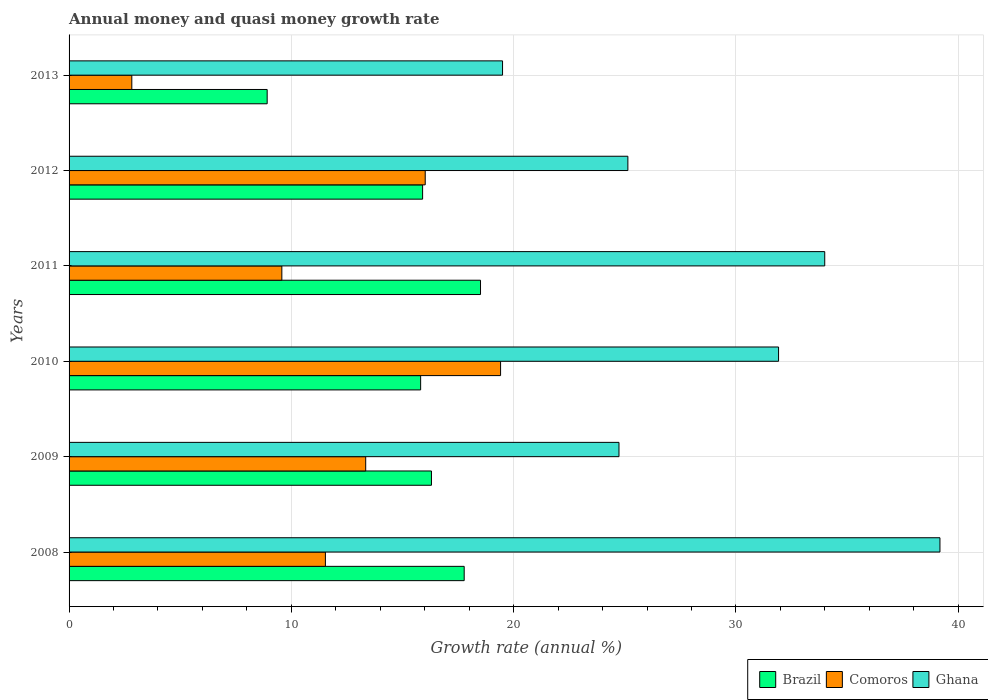How many different coloured bars are there?
Keep it short and to the point. 3. How many groups of bars are there?
Offer a very short reply. 6. Are the number of bars on each tick of the Y-axis equal?
Your answer should be very brief. Yes. How many bars are there on the 6th tick from the top?
Your answer should be very brief. 3. How many bars are there on the 1st tick from the bottom?
Ensure brevity in your answer.  3. What is the label of the 5th group of bars from the top?
Ensure brevity in your answer.  2009. In how many cases, is the number of bars for a given year not equal to the number of legend labels?
Provide a short and direct response. 0. What is the growth rate in Brazil in 2008?
Provide a succinct answer. 17.78. Across all years, what is the maximum growth rate in Brazil?
Give a very brief answer. 18.51. Across all years, what is the minimum growth rate in Comoros?
Your answer should be compact. 2.82. In which year was the growth rate in Ghana maximum?
Keep it short and to the point. 2008. What is the total growth rate in Brazil in the graph?
Provide a succinct answer. 93.22. What is the difference between the growth rate in Ghana in 2008 and that in 2012?
Ensure brevity in your answer.  14.04. What is the difference between the growth rate in Ghana in 2013 and the growth rate in Brazil in 2012?
Offer a very short reply. 3.6. What is the average growth rate in Brazil per year?
Offer a terse response. 15.54. In the year 2013, what is the difference between the growth rate in Ghana and growth rate in Brazil?
Provide a short and direct response. 10.59. In how many years, is the growth rate in Ghana greater than 14 %?
Keep it short and to the point. 6. What is the ratio of the growth rate in Comoros in 2008 to that in 2013?
Ensure brevity in your answer.  4.09. Is the growth rate in Comoros in 2010 less than that in 2013?
Your answer should be very brief. No. Is the difference between the growth rate in Ghana in 2008 and 2013 greater than the difference between the growth rate in Brazil in 2008 and 2013?
Your response must be concise. Yes. What is the difference between the highest and the second highest growth rate in Brazil?
Your answer should be compact. 0.73. What is the difference between the highest and the lowest growth rate in Comoros?
Offer a very short reply. 16.59. What does the 2nd bar from the top in 2012 represents?
Give a very brief answer. Comoros. What does the 2nd bar from the bottom in 2012 represents?
Your answer should be very brief. Comoros. Are the values on the major ticks of X-axis written in scientific E-notation?
Ensure brevity in your answer.  No. How many legend labels are there?
Offer a very short reply. 3. What is the title of the graph?
Offer a terse response. Annual money and quasi money growth rate. What is the label or title of the X-axis?
Make the answer very short. Growth rate (annual %). What is the label or title of the Y-axis?
Provide a short and direct response. Years. What is the Growth rate (annual %) in Brazil in 2008?
Give a very brief answer. 17.78. What is the Growth rate (annual %) in Comoros in 2008?
Offer a terse response. 11.53. What is the Growth rate (annual %) in Ghana in 2008?
Give a very brief answer. 39.18. What is the Growth rate (annual %) of Brazil in 2009?
Make the answer very short. 16.3. What is the Growth rate (annual %) of Comoros in 2009?
Your answer should be compact. 13.34. What is the Growth rate (annual %) of Ghana in 2009?
Keep it short and to the point. 24.74. What is the Growth rate (annual %) of Brazil in 2010?
Offer a very short reply. 15.82. What is the Growth rate (annual %) in Comoros in 2010?
Provide a succinct answer. 19.41. What is the Growth rate (annual %) of Ghana in 2010?
Your answer should be very brief. 31.92. What is the Growth rate (annual %) of Brazil in 2011?
Offer a very short reply. 18.51. What is the Growth rate (annual %) of Comoros in 2011?
Make the answer very short. 9.57. What is the Growth rate (annual %) of Ghana in 2011?
Give a very brief answer. 33.99. What is the Growth rate (annual %) of Brazil in 2012?
Make the answer very short. 15.9. What is the Growth rate (annual %) of Comoros in 2012?
Provide a succinct answer. 16.02. What is the Growth rate (annual %) in Ghana in 2012?
Your answer should be compact. 25.14. What is the Growth rate (annual %) of Brazil in 2013?
Offer a terse response. 8.91. What is the Growth rate (annual %) of Comoros in 2013?
Provide a succinct answer. 2.82. What is the Growth rate (annual %) of Ghana in 2013?
Keep it short and to the point. 19.5. Across all years, what is the maximum Growth rate (annual %) of Brazil?
Provide a short and direct response. 18.51. Across all years, what is the maximum Growth rate (annual %) of Comoros?
Make the answer very short. 19.41. Across all years, what is the maximum Growth rate (annual %) in Ghana?
Offer a very short reply. 39.18. Across all years, what is the minimum Growth rate (annual %) of Brazil?
Your answer should be very brief. 8.91. Across all years, what is the minimum Growth rate (annual %) of Comoros?
Ensure brevity in your answer.  2.82. Across all years, what is the minimum Growth rate (annual %) of Ghana?
Provide a short and direct response. 19.5. What is the total Growth rate (annual %) of Brazil in the graph?
Your answer should be compact. 93.22. What is the total Growth rate (annual %) of Comoros in the graph?
Provide a short and direct response. 72.7. What is the total Growth rate (annual %) of Ghana in the graph?
Your answer should be compact. 174.47. What is the difference between the Growth rate (annual %) of Brazil in 2008 and that in 2009?
Offer a terse response. 1.47. What is the difference between the Growth rate (annual %) of Comoros in 2008 and that in 2009?
Offer a very short reply. -1.81. What is the difference between the Growth rate (annual %) in Ghana in 2008 and that in 2009?
Offer a terse response. 14.44. What is the difference between the Growth rate (annual %) of Brazil in 2008 and that in 2010?
Provide a succinct answer. 1.96. What is the difference between the Growth rate (annual %) in Comoros in 2008 and that in 2010?
Provide a succinct answer. -7.88. What is the difference between the Growth rate (annual %) of Ghana in 2008 and that in 2010?
Your response must be concise. 7.26. What is the difference between the Growth rate (annual %) of Brazil in 2008 and that in 2011?
Your answer should be very brief. -0.73. What is the difference between the Growth rate (annual %) in Comoros in 2008 and that in 2011?
Provide a succinct answer. 1.96. What is the difference between the Growth rate (annual %) in Ghana in 2008 and that in 2011?
Give a very brief answer. 5.18. What is the difference between the Growth rate (annual %) in Brazil in 2008 and that in 2012?
Keep it short and to the point. 1.87. What is the difference between the Growth rate (annual %) in Comoros in 2008 and that in 2012?
Your answer should be compact. -4.49. What is the difference between the Growth rate (annual %) in Ghana in 2008 and that in 2012?
Give a very brief answer. 14.04. What is the difference between the Growth rate (annual %) in Brazil in 2008 and that in 2013?
Make the answer very short. 8.86. What is the difference between the Growth rate (annual %) in Comoros in 2008 and that in 2013?
Your answer should be compact. 8.71. What is the difference between the Growth rate (annual %) of Ghana in 2008 and that in 2013?
Provide a short and direct response. 19.68. What is the difference between the Growth rate (annual %) of Brazil in 2009 and that in 2010?
Keep it short and to the point. 0.49. What is the difference between the Growth rate (annual %) in Comoros in 2009 and that in 2010?
Give a very brief answer. -6.07. What is the difference between the Growth rate (annual %) in Ghana in 2009 and that in 2010?
Provide a succinct answer. -7.18. What is the difference between the Growth rate (annual %) of Brazil in 2009 and that in 2011?
Provide a short and direct response. -2.21. What is the difference between the Growth rate (annual %) of Comoros in 2009 and that in 2011?
Your answer should be compact. 3.77. What is the difference between the Growth rate (annual %) in Ghana in 2009 and that in 2011?
Provide a succinct answer. -9.26. What is the difference between the Growth rate (annual %) in Brazil in 2009 and that in 2012?
Your answer should be compact. 0.4. What is the difference between the Growth rate (annual %) in Comoros in 2009 and that in 2012?
Your answer should be very brief. -2.68. What is the difference between the Growth rate (annual %) in Ghana in 2009 and that in 2012?
Keep it short and to the point. -0.4. What is the difference between the Growth rate (annual %) of Brazil in 2009 and that in 2013?
Your response must be concise. 7.39. What is the difference between the Growth rate (annual %) of Comoros in 2009 and that in 2013?
Make the answer very short. 10.52. What is the difference between the Growth rate (annual %) of Ghana in 2009 and that in 2013?
Your answer should be compact. 5.24. What is the difference between the Growth rate (annual %) of Brazil in 2010 and that in 2011?
Provide a succinct answer. -2.69. What is the difference between the Growth rate (annual %) of Comoros in 2010 and that in 2011?
Provide a succinct answer. 9.84. What is the difference between the Growth rate (annual %) in Ghana in 2010 and that in 2011?
Keep it short and to the point. -2.08. What is the difference between the Growth rate (annual %) in Brazil in 2010 and that in 2012?
Your answer should be very brief. -0.09. What is the difference between the Growth rate (annual %) in Comoros in 2010 and that in 2012?
Offer a very short reply. 3.39. What is the difference between the Growth rate (annual %) of Ghana in 2010 and that in 2012?
Provide a succinct answer. 6.78. What is the difference between the Growth rate (annual %) of Brazil in 2010 and that in 2013?
Keep it short and to the point. 6.9. What is the difference between the Growth rate (annual %) in Comoros in 2010 and that in 2013?
Keep it short and to the point. 16.59. What is the difference between the Growth rate (annual %) in Ghana in 2010 and that in 2013?
Ensure brevity in your answer.  12.42. What is the difference between the Growth rate (annual %) in Brazil in 2011 and that in 2012?
Ensure brevity in your answer.  2.61. What is the difference between the Growth rate (annual %) in Comoros in 2011 and that in 2012?
Provide a short and direct response. -6.45. What is the difference between the Growth rate (annual %) in Ghana in 2011 and that in 2012?
Offer a terse response. 8.86. What is the difference between the Growth rate (annual %) of Brazil in 2011 and that in 2013?
Keep it short and to the point. 9.6. What is the difference between the Growth rate (annual %) in Comoros in 2011 and that in 2013?
Your answer should be compact. 6.75. What is the difference between the Growth rate (annual %) of Ghana in 2011 and that in 2013?
Your response must be concise. 14.49. What is the difference between the Growth rate (annual %) in Brazil in 2012 and that in 2013?
Provide a short and direct response. 6.99. What is the difference between the Growth rate (annual %) in Comoros in 2012 and that in 2013?
Give a very brief answer. 13.2. What is the difference between the Growth rate (annual %) of Ghana in 2012 and that in 2013?
Provide a short and direct response. 5.64. What is the difference between the Growth rate (annual %) of Brazil in 2008 and the Growth rate (annual %) of Comoros in 2009?
Give a very brief answer. 4.43. What is the difference between the Growth rate (annual %) of Brazil in 2008 and the Growth rate (annual %) of Ghana in 2009?
Your answer should be compact. -6.96. What is the difference between the Growth rate (annual %) in Comoros in 2008 and the Growth rate (annual %) in Ghana in 2009?
Keep it short and to the point. -13.21. What is the difference between the Growth rate (annual %) of Brazil in 2008 and the Growth rate (annual %) of Comoros in 2010?
Keep it short and to the point. -1.64. What is the difference between the Growth rate (annual %) of Brazil in 2008 and the Growth rate (annual %) of Ghana in 2010?
Provide a succinct answer. -14.14. What is the difference between the Growth rate (annual %) of Comoros in 2008 and the Growth rate (annual %) of Ghana in 2010?
Your answer should be compact. -20.39. What is the difference between the Growth rate (annual %) in Brazil in 2008 and the Growth rate (annual %) in Comoros in 2011?
Provide a succinct answer. 8.2. What is the difference between the Growth rate (annual %) of Brazil in 2008 and the Growth rate (annual %) of Ghana in 2011?
Your response must be concise. -16.22. What is the difference between the Growth rate (annual %) in Comoros in 2008 and the Growth rate (annual %) in Ghana in 2011?
Offer a very short reply. -22.46. What is the difference between the Growth rate (annual %) in Brazil in 2008 and the Growth rate (annual %) in Comoros in 2012?
Keep it short and to the point. 1.75. What is the difference between the Growth rate (annual %) in Brazil in 2008 and the Growth rate (annual %) in Ghana in 2012?
Keep it short and to the point. -7.36. What is the difference between the Growth rate (annual %) of Comoros in 2008 and the Growth rate (annual %) of Ghana in 2012?
Your answer should be very brief. -13.61. What is the difference between the Growth rate (annual %) of Brazil in 2008 and the Growth rate (annual %) of Comoros in 2013?
Provide a short and direct response. 14.95. What is the difference between the Growth rate (annual %) in Brazil in 2008 and the Growth rate (annual %) in Ghana in 2013?
Your answer should be very brief. -1.73. What is the difference between the Growth rate (annual %) of Comoros in 2008 and the Growth rate (annual %) of Ghana in 2013?
Your answer should be compact. -7.97. What is the difference between the Growth rate (annual %) of Brazil in 2009 and the Growth rate (annual %) of Comoros in 2010?
Provide a succinct answer. -3.11. What is the difference between the Growth rate (annual %) in Brazil in 2009 and the Growth rate (annual %) in Ghana in 2010?
Make the answer very short. -15.62. What is the difference between the Growth rate (annual %) in Comoros in 2009 and the Growth rate (annual %) in Ghana in 2010?
Make the answer very short. -18.57. What is the difference between the Growth rate (annual %) of Brazil in 2009 and the Growth rate (annual %) of Comoros in 2011?
Provide a short and direct response. 6.73. What is the difference between the Growth rate (annual %) of Brazil in 2009 and the Growth rate (annual %) of Ghana in 2011?
Make the answer very short. -17.69. What is the difference between the Growth rate (annual %) of Comoros in 2009 and the Growth rate (annual %) of Ghana in 2011?
Make the answer very short. -20.65. What is the difference between the Growth rate (annual %) in Brazil in 2009 and the Growth rate (annual %) in Comoros in 2012?
Your answer should be compact. 0.28. What is the difference between the Growth rate (annual %) in Brazil in 2009 and the Growth rate (annual %) in Ghana in 2012?
Give a very brief answer. -8.84. What is the difference between the Growth rate (annual %) of Comoros in 2009 and the Growth rate (annual %) of Ghana in 2012?
Make the answer very short. -11.79. What is the difference between the Growth rate (annual %) in Brazil in 2009 and the Growth rate (annual %) in Comoros in 2013?
Give a very brief answer. 13.48. What is the difference between the Growth rate (annual %) in Brazil in 2009 and the Growth rate (annual %) in Ghana in 2013?
Offer a terse response. -3.2. What is the difference between the Growth rate (annual %) in Comoros in 2009 and the Growth rate (annual %) in Ghana in 2013?
Keep it short and to the point. -6.16. What is the difference between the Growth rate (annual %) of Brazil in 2010 and the Growth rate (annual %) of Comoros in 2011?
Ensure brevity in your answer.  6.24. What is the difference between the Growth rate (annual %) in Brazil in 2010 and the Growth rate (annual %) in Ghana in 2011?
Your answer should be very brief. -18.18. What is the difference between the Growth rate (annual %) of Comoros in 2010 and the Growth rate (annual %) of Ghana in 2011?
Offer a very short reply. -14.58. What is the difference between the Growth rate (annual %) in Brazil in 2010 and the Growth rate (annual %) in Comoros in 2012?
Provide a short and direct response. -0.21. What is the difference between the Growth rate (annual %) in Brazil in 2010 and the Growth rate (annual %) in Ghana in 2012?
Offer a terse response. -9.32. What is the difference between the Growth rate (annual %) in Comoros in 2010 and the Growth rate (annual %) in Ghana in 2012?
Provide a succinct answer. -5.73. What is the difference between the Growth rate (annual %) in Brazil in 2010 and the Growth rate (annual %) in Comoros in 2013?
Provide a short and direct response. 12.99. What is the difference between the Growth rate (annual %) of Brazil in 2010 and the Growth rate (annual %) of Ghana in 2013?
Give a very brief answer. -3.68. What is the difference between the Growth rate (annual %) of Comoros in 2010 and the Growth rate (annual %) of Ghana in 2013?
Ensure brevity in your answer.  -0.09. What is the difference between the Growth rate (annual %) in Brazil in 2011 and the Growth rate (annual %) in Comoros in 2012?
Provide a short and direct response. 2.49. What is the difference between the Growth rate (annual %) in Brazil in 2011 and the Growth rate (annual %) in Ghana in 2012?
Ensure brevity in your answer.  -6.63. What is the difference between the Growth rate (annual %) of Comoros in 2011 and the Growth rate (annual %) of Ghana in 2012?
Keep it short and to the point. -15.57. What is the difference between the Growth rate (annual %) of Brazil in 2011 and the Growth rate (annual %) of Comoros in 2013?
Provide a short and direct response. 15.69. What is the difference between the Growth rate (annual %) of Brazil in 2011 and the Growth rate (annual %) of Ghana in 2013?
Give a very brief answer. -0.99. What is the difference between the Growth rate (annual %) in Comoros in 2011 and the Growth rate (annual %) in Ghana in 2013?
Make the answer very short. -9.93. What is the difference between the Growth rate (annual %) of Brazil in 2012 and the Growth rate (annual %) of Comoros in 2013?
Keep it short and to the point. 13.08. What is the difference between the Growth rate (annual %) in Brazil in 2012 and the Growth rate (annual %) in Ghana in 2013?
Make the answer very short. -3.6. What is the difference between the Growth rate (annual %) in Comoros in 2012 and the Growth rate (annual %) in Ghana in 2013?
Provide a succinct answer. -3.48. What is the average Growth rate (annual %) in Brazil per year?
Your answer should be compact. 15.54. What is the average Growth rate (annual %) in Comoros per year?
Your answer should be compact. 12.12. What is the average Growth rate (annual %) of Ghana per year?
Provide a succinct answer. 29.08. In the year 2008, what is the difference between the Growth rate (annual %) in Brazil and Growth rate (annual %) in Comoros?
Provide a short and direct response. 6.24. In the year 2008, what is the difference between the Growth rate (annual %) of Brazil and Growth rate (annual %) of Ghana?
Offer a very short reply. -21.4. In the year 2008, what is the difference between the Growth rate (annual %) of Comoros and Growth rate (annual %) of Ghana?
Ensure brevity in your answer.  -27.65. In the year 2009, what is the difference between the Growth rate (annual %) of Brazil and Growth rate (annual %) of Comoros?
Keep it short and to the point. 2.96. In the year 2009, what is the difference between the Growth rate (annual %) of Brazil and Growth rate (annual %) of Ghana?
Give a very brief answer. -8.44. In the year 2009, what is the difference between the Growth rate (annual %) in Comoros and Growth rate (annual %) in Ghana?
Ensure brevity in your answer.  -11.39. In the year 2010, what is the difference between the Growth rate (annual %) of Brazil and Growth rate (annual %) of Comoros?
Your response must be concise. -3.6. In the year 2010, what is the difference between the Growth rate (annual %) in Brazil and Growth rate (annual %) in Ghana?
Provide a short and direct response. -16.1. In the year 2010, what is the difference between the Growth rate (annual %) of Comoros and Growth rate (annual %) of Ghana?
Give a very brief answer. -12.51. In the year 2011, what is the difference between the Growth rate (annual %) in Brazil and Growth rate (annual %) in Comoros?
Offer a very short reply. 8.94. In the year 2011, what is the difference between the Growth rate (annual %) in Brazil and Growth rate (annual %) in Ghana?
Offer a terse response. -15.48. In the year 2011, what is the difference between the Growth rate (annual %) of Comoros and Growth rate (annual %) of Ghana?
Make the answer very short. -24.42. In the year 2012, what is the difference between the Growth rate (annual %) of Brazil and Growth rate (annual %) of Comoros?
Ensure brevity in your answer.  -0.12. In the year 2012, what is the difference between the Growth rate (annual %) of Brazil and Growth rate (annual %) of Ghana?
Provide a short and direct response. -9.23. In the year 2012, what is the difference between the Growth rate (annual %) of Comoros and Growth rate (annual %) of Ghana?
Keep it short and to the point. -9.12. In the year 2013, what is the difference between the Growth rate (annual %) of Brazil and Growth rate (annual %) of Comoros?
Give a very brief answer. 6.09. In the year 2013, what is the difference between the Growth rate (annual %) in Brazil and Growth rate (annual %) in Ghana?
Make the answer very short. -10.59. In the year 2013, what is the difference between the Growth rate (annual %) in Comoros and Growth rate (annual %) in Ghana?
Offer a terse response. -16.68. What is the ratio of the Growth rate (annual %) of Brazil in 2008 to that in 2009?
Provide a succinct answer. 1.09. What is the ratio of the Growth rate (annual %) in Comoros in 2008 to that in 2009?
Your answer should be very brief. 0.86. What is the ratio of the Growth rate (annual %) of Ghana in 2008 to that in 2009?
Make the answer very short. 1.58. What is the ratio of the Growth rate (annual %) of Brazil in 2008 to that in 2010?
Offer a terse response. 1.12. What is the ratio of the Growth rate (annual %) of Comoros in 2008 to that in 2010?
Your response must be concise. 0.59. What is the ratio of the Growth rate (annual %) in Ghana in 2008 to that in 2010?
Provide a short and direct response. 1.23. What is the ratio of the Growth rate (annual %) of Brazil in 2008 to that in 2011?
Provide a short and direct response. 0.96. What is the ratio of the Growth rate (annual %) in Comoros in 2008 to that in 2011?
Ensure brevity in your answer.  1.2. What is the ratio of the Growth rate (annual %) in Ghana in 2008 to that in 2011?
Your response must be concise. 1.15. What is the ratio of the Growth rate (annual %) in Brazil in 2008 to that in 2012?
Ensure brevity in your answer.  1.12. What is the ratio of the Growth rate (annual %) in Comoros in 2008 to that in 2012?
Keep it short and to the point. 0.72. What is the ratio of the Growth rate (annual %) of Ghana in 2008 to that in 2012?
Give a very brief answer. 1.56. What is the ratio of the Growth rate (annual %) of Brazil in 2008 to that in 2013?
Offer a terse response. 1.99. What is the ratio of the Growth rate (annual %) of Comoros in 2008 to that in 2013?
Make the answer very short. 4.09. What is the ratio of the Growth rate (annual %) in Ghana in 2008 to that in 2013?
Give a very brief answer. 2.01. What is the ratio of the Growth rate (annual %) of Brazil in 2009 to that in 2010?
Offer a very short reply. 1.03. What is the ratio of the Growth rate (annual %) of Comoros in 2009 to that in 2010?
Offer a very short reply. 0.69. What is the ratio of the Growth rate (annual %) in Ghana in 2009 to that in 2010?
Offer a very short reply. 0.78. What is the ratio of the Growth rate (annual %) in Brazil in 2009 to that in 2011?
Your answer should be compact. 0.88. What is the ratio of the Growth rate (annual %) of Comoros in 2009 to that in 2011?
Keep it short and to the point. 1.39. What is the ratio of the Growth rate (annual %) of Ghana in 2009 to that in 2011?
Offer a terse response. 0.73. What is the ratio of the Growth rate (annual %) in Comoros in 2009 to that in 2012?
Your response must be concise. 0.83. What is the ratio of the Growth rate (annual %) of Ghana in 2009 to that in 2012?
Give a very brief answer. 0.98. What is the ratio of the Growth rate (annual %) of Brazil in 2009 to that in 2013?
Ensure brevity in your answer.  1.83. What is the ratio of the Growth rate (annual %) in Comoros in 2009 to that in 2013?
Make the answer very short. 4.73. What is the ratio of the Growth rate (annual %) of Ghana in 2009 to that in 2013?
Provide a succinct answer. 1.27. What is the ratio of the Growth rate (annual %) of Brazil in 2010 to that in 2011?
Offer a very short reply. 0.85. What is the ratio of the Growth rate (annual %) of Comoros in 2010 to that in 2011?
Provide a short and direct response. 2.03. What is the ratio of the Growth rate (annual %) of Ghana in 2010 to that in 2011?
Your answer should be compact. 0.94. What is the ratio of the Growth rate (annual %) of Brazil in 2010 to that in 2012?
Offer a very short reply. 0.99. What is the ratio of the Growth rate (annual %) in Comoros in 2010 to that in 2012?
Make the answer very short. 1.21. What is the ratio of the Growth rate (annual %) of Ghana in 2010 to that in 2012?
Your answer should be compact. 1.27. What is the ratio of the Growth rate (annual %) in Brazil in 2010 to that in 2013?
Make the answer very short. 1.77. What is the ratio of the Growth rate (annual %) of Comoros in 2010 to that in 2013?
Ensure brevity in your answer.  6.88. What is the ratio of the Growth rate (annual %) in Ghana in 2010 to that in 2013?
Provide a short and direct response. 1.64. What is the ratio of the Growth rate (annual %) in Brazil in 2011 to that in 2012?
Provide a short and direct response. 1.16. What is the ratio of the Growth rate (annual %) of Comoros in 2011 to that in 2012?
Your answer should be very brief. 0.6. What is the ratio of the Growth rate (annual %) of Ghana in 2011 to that in 2012?
Your answer should be compact. 1.35. What is the ratio of the Growth rate (annual %) of Brazil in 2011 to that in 2013?
Give a very brief answer. 2.08. What is the ratio of the Growth rate (annual %) in Comoros in 2011 to that in 2013?
Ensure brevity in your answer.  3.39. What is the ratio of the Growth rate (annual %) in Ghana in 2011 to that in 2013?
Make the answer very short. 1.74. What is the ratio of the Growth rate (annual %) of Brazil in 2012 to that in 2013?
Keep it short and to the point. 1.78. What is the ratio of the Growth rate (annual %) in Comoros in 2012 to that in 2013?
Make the answer very short. 5.68. What is the ratio of the Growth rate (annual %) in Ghana in 2012 to that in 2013?
Keep it short and to the point. 1.29. What is the difference between the highest and the second highest Growth rate (annual %) in Brazil?
Your answer should be compact. 0.73. What is the difference between the highest and the second highest Growth rate (annual %) in Comoros?
Offer a very short reply. 3.39. What is the difference between the highest and the second highest Growth rate (annual %) in Ghana?
Your answer should be compact. 5.18. What is the difference between the highest and the lowest Growth rate (annual %) in Brazil?
Offer a very short reply. 9.6. What is the difference between the highest and the lowest Growth rate (annual %) of Comoros?
Keep it short and to the point. 16.59. What is the difference between the highest and the lowest Growth rate (annual %) in Ghana?
Provide a short and direct response. 19.68. 